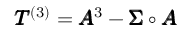Convert formula to latex. <formula><loc_0><loc_0><loc_500><loc_500>\pm b { T } ^ { ( 3 ) } = \pm b { A } ^ { 3 } - \pm b { \Sigma } \circ \pm b { A }</formula> 